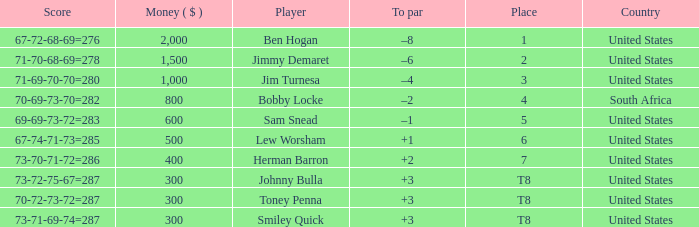What is the position of the player with a total of more than 300 in earnings and a score breakdown of 71-69-70-70, equaling 280? 3.0. 